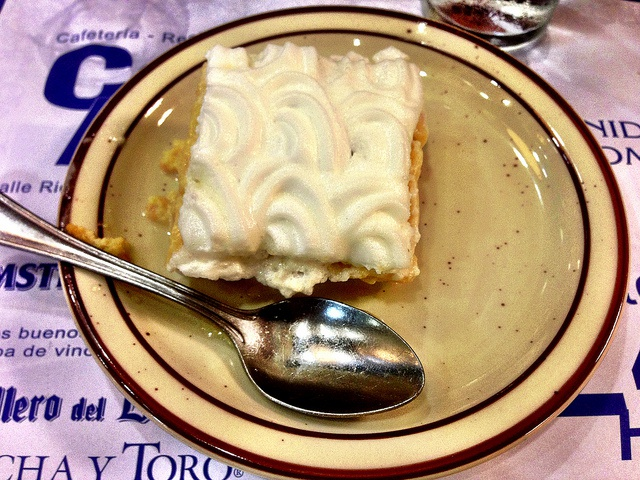Describe the objects in this image and their specific colors. I can see cake in navy, beige, and tan tones, dining table in navy, lightpink, pink, darkgray, and gray tones, spoon in navy, black, white, gray, and maroon tones, and cup in navy, maroon, black, white, and gray tones in this image. 